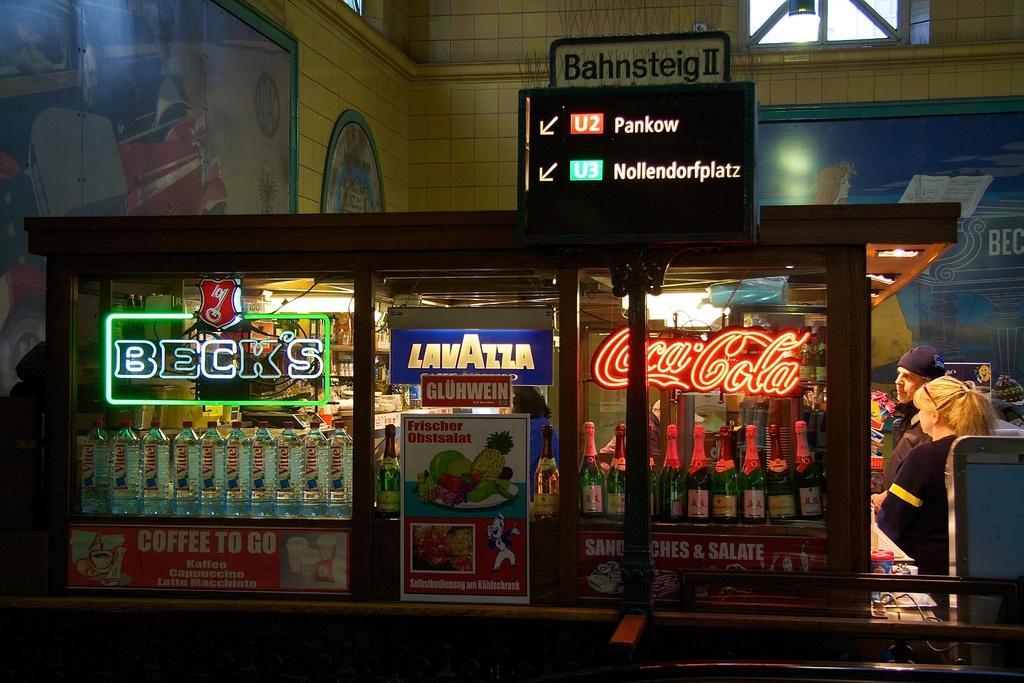Can you describe this image briefly? In this picture we can see bottles, banners, direction board, wall with frames, windows and two persons. 